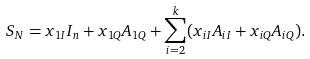Convert formula to latex. <formula><loc_0><loc_0><loc_500><loc_500>S _ { N } = x _ { 1 I } I _ { n } + x _ { 1 Q } A _ { 1 Q } + \sum _ { i = 2 } ^ { k } ( x _ { i I } A _ { i I } + x _ { i Q } A _ { i Q } ) .</formula> 